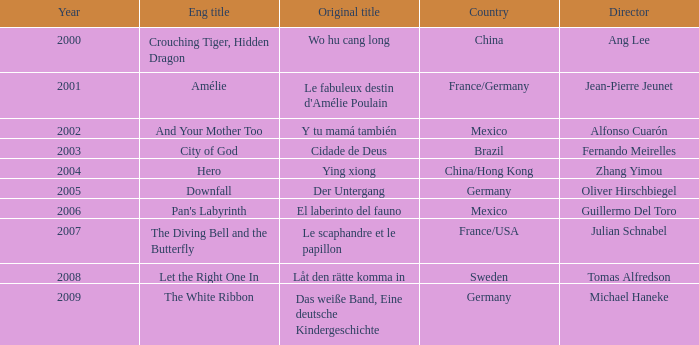Tell me the country for julian schnabel France/USA. 